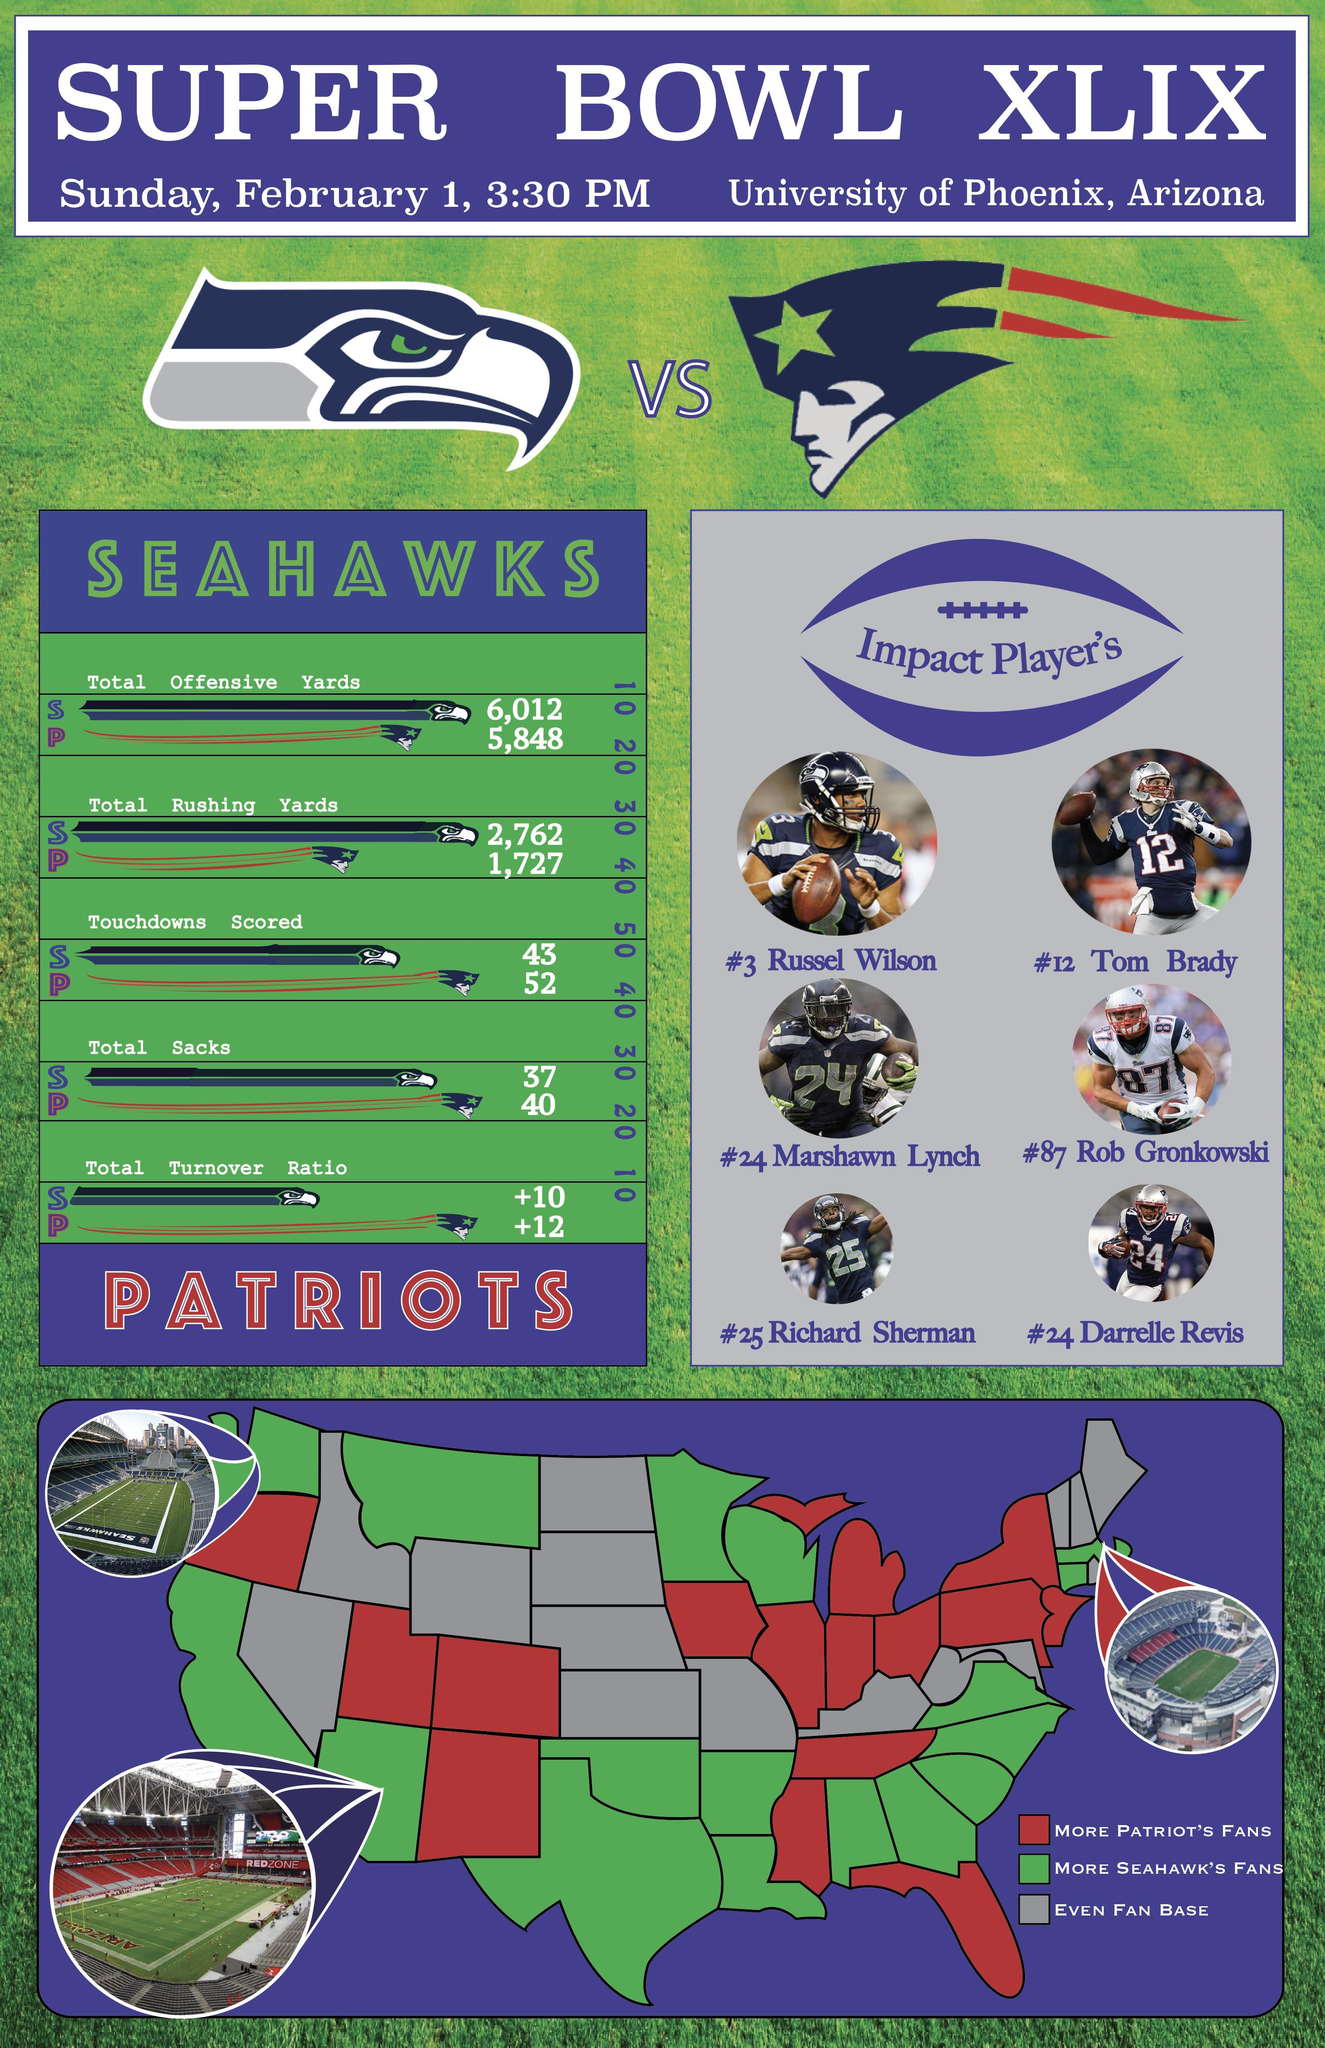Who had a higher total offensive and rushing yards?
Answer the question with a short phrase. Seahawks How many states had more Seattle Seahawks fans? 17 Which stadium is displayed on the left bottom of the map? University of Phoenix, Arizona How many states had more Seattle New England Patriots fans? 16 Who has a higher total of touchdowns, sacks and turnover ration? Patriots 